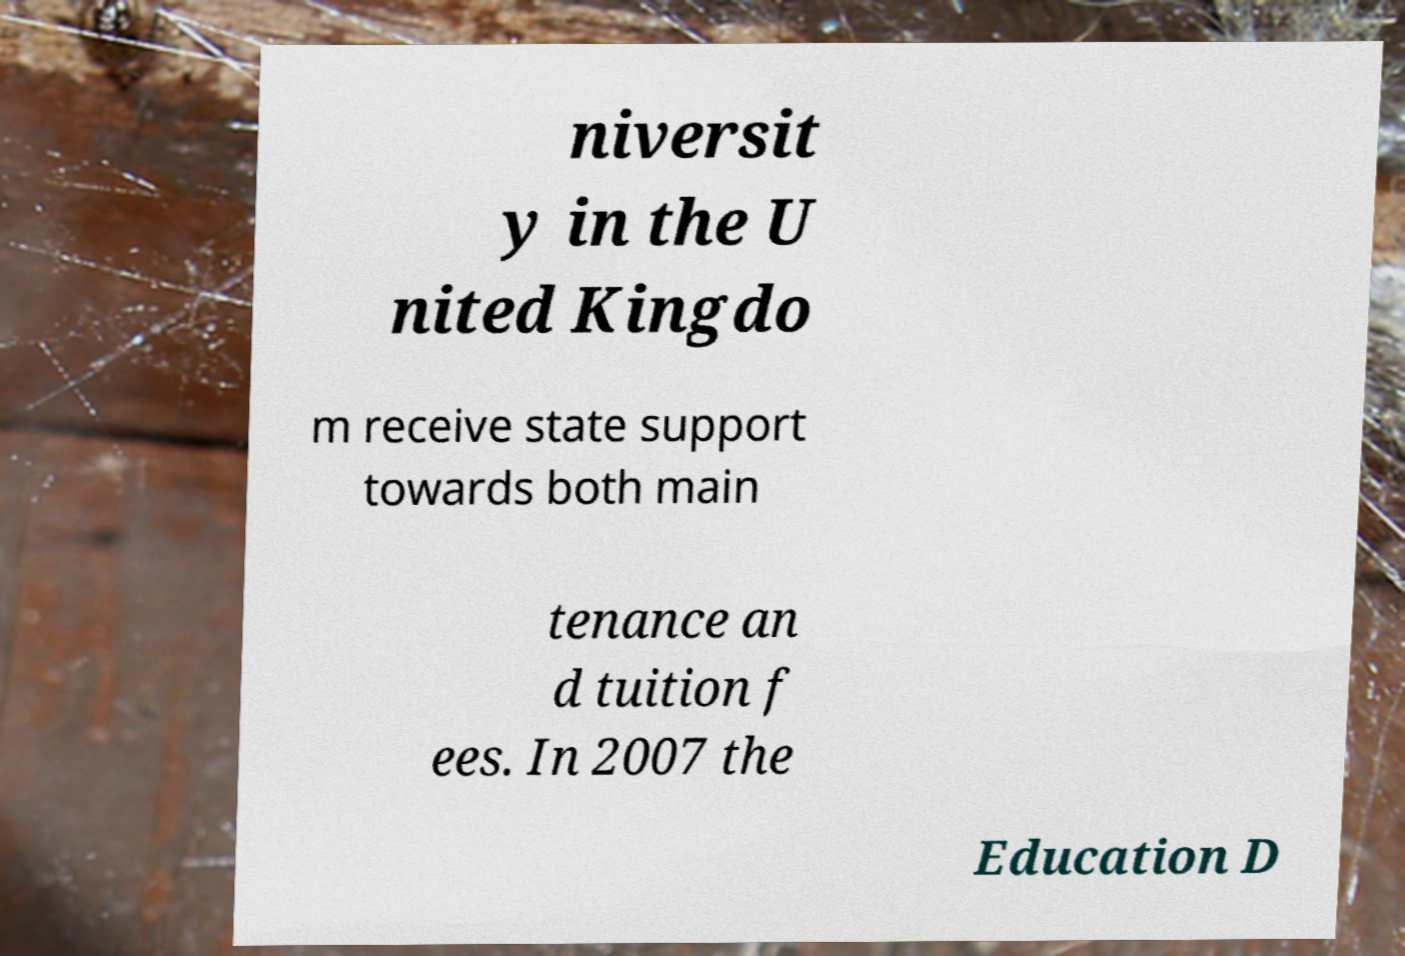There's text embedded in this image that I need extracted. Can you transcribe it verbatim? niversit y in the U nited Kingdo m receive state support towards both main tenance an d tuition f ees. In 2007 the Education D 